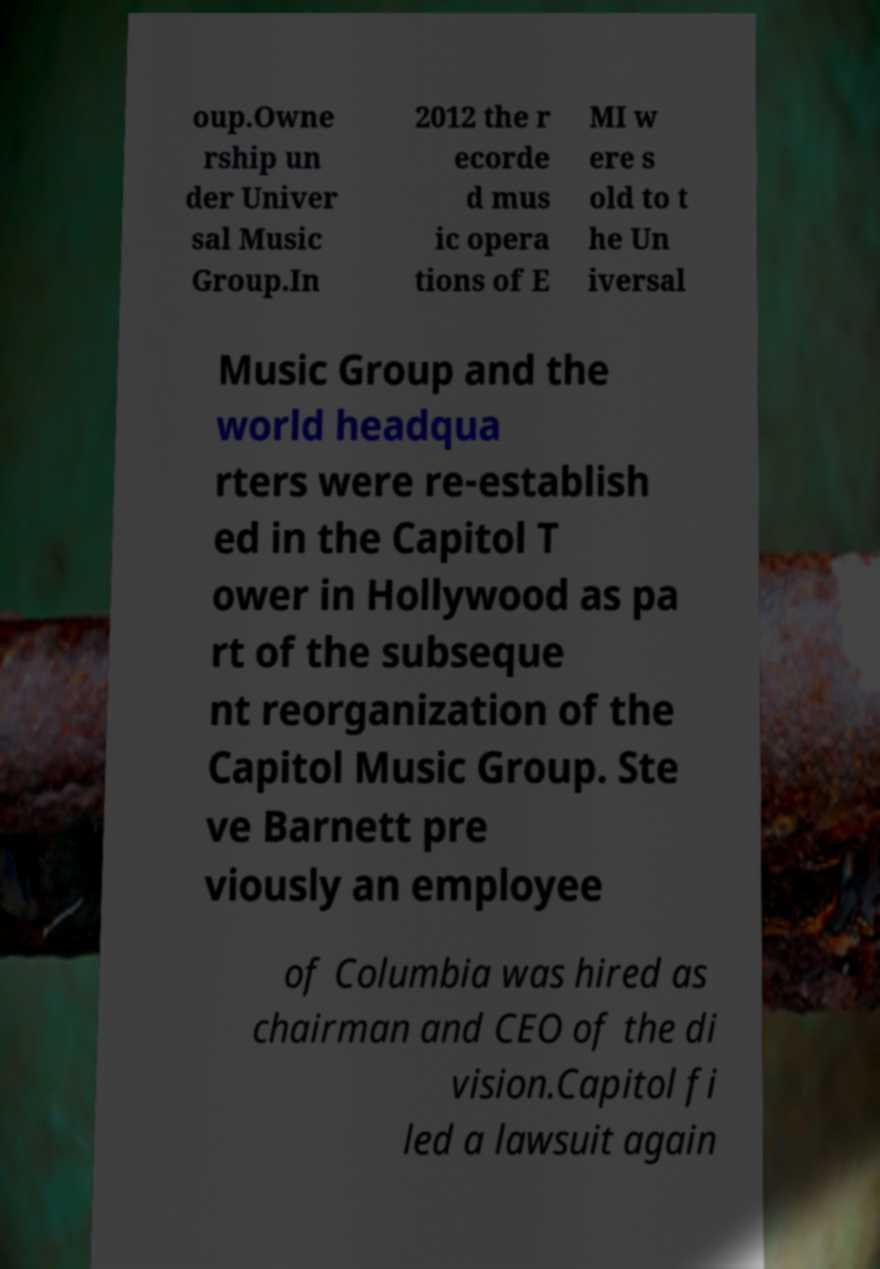Please read and relay the text visible in this image. What does it say? oup.Owne rship un der Univer sal Music Group.In 2012 the r ecorde d mus ic opera tions of E MI w ere s old to t he Un iversal Music Group and the world headqua rters were re-establish ed in the Capitol T ower in Hollywood as pa rt of the subseque nt reorganization of the Capitol Music Group. Ste ve Barnett pre viously an employee of Columbia was hired as chairman and CEO of the di vision.Capitol fi led a lawsuit again 